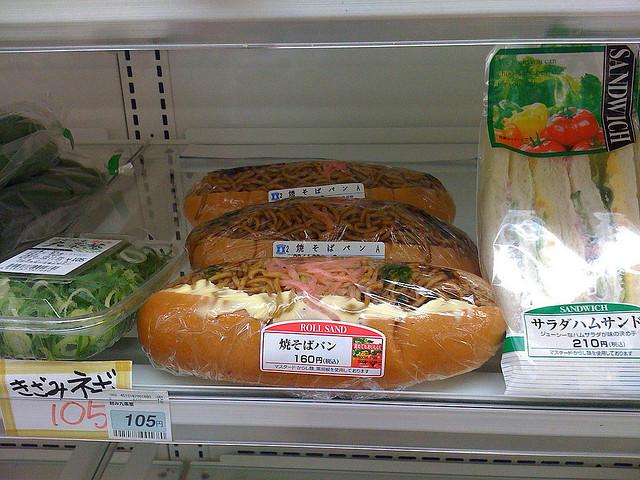How many sandwiches do you see?
Quick response, please. 3. Is there donuts here?
Concise answer only. No. What language are these labels in?
Write a very short answer. Chinese. How much do the onions cost?
Answer briefly. 105. 